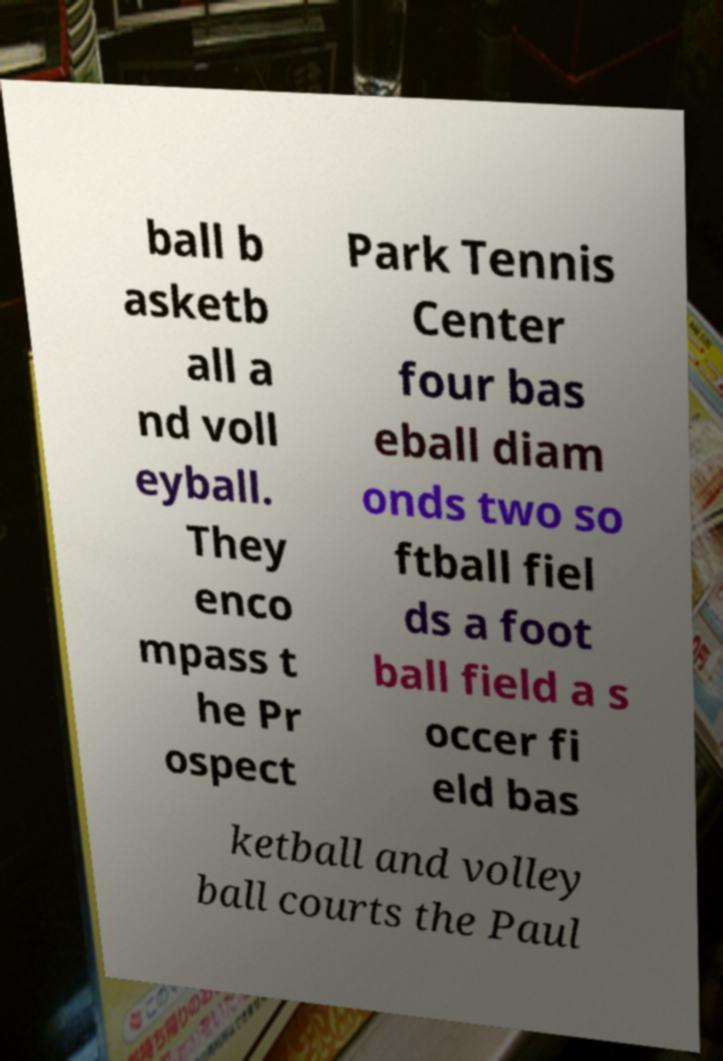Could you assist in decoding the text presented in this image and type it out clearly? ball b asketb all a nd voll eyball. They enco mpass t he Pr ospect Park Tennis Center four bas eball diam onds two so ftball fiel ds a foot ball field a s occer fi eld bas ketball and volley ball courts the Paul 